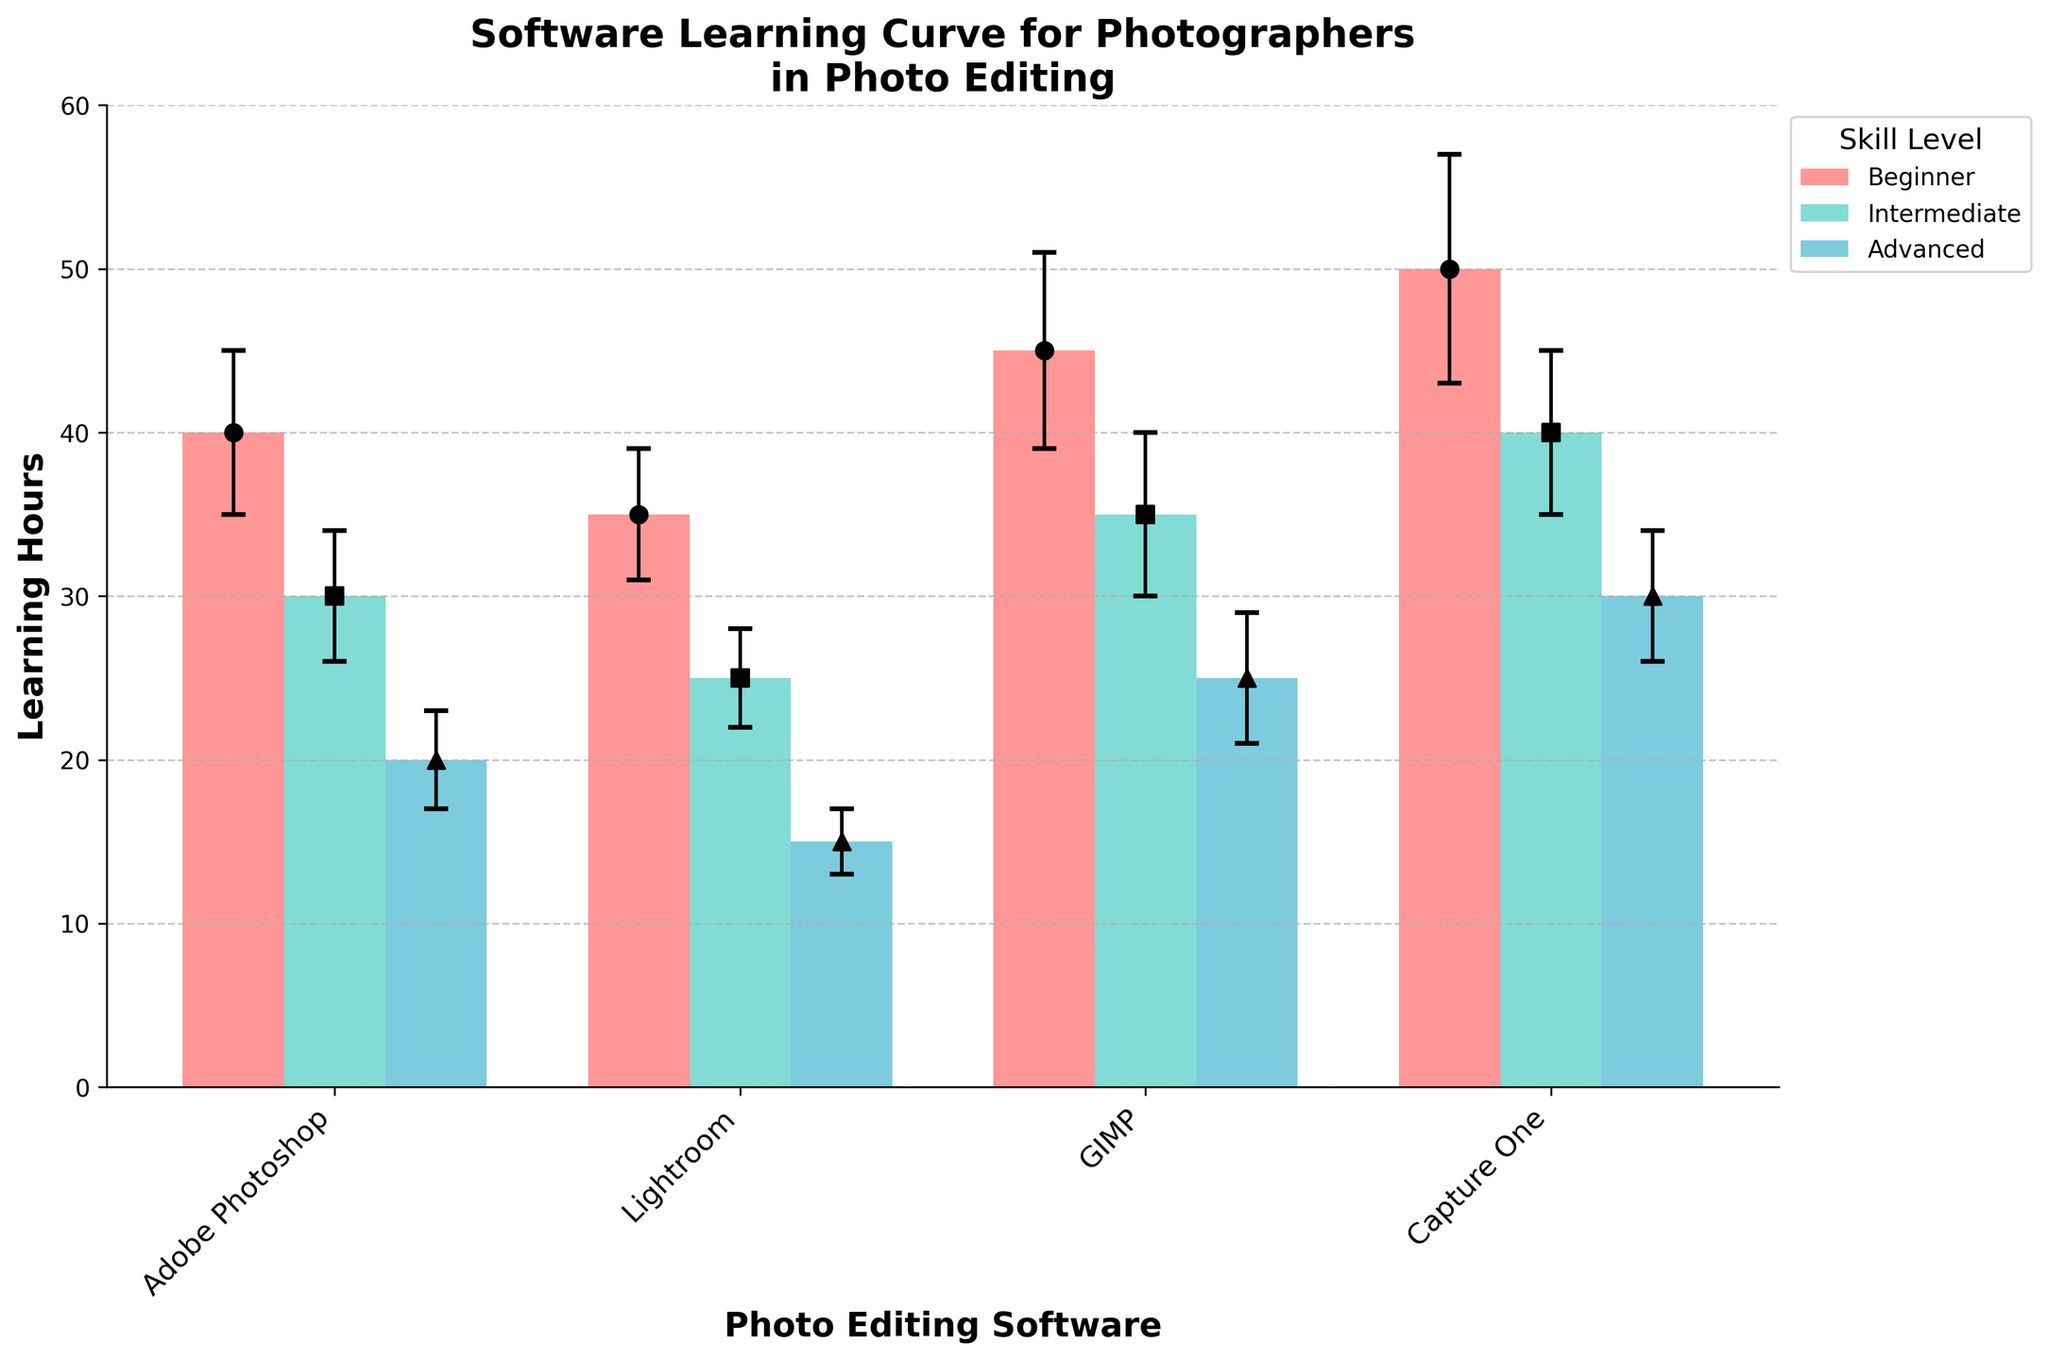What is the title of the figure? The title of the figure is located at the top and usually provides a summary of what the figure represents.
Answer: Software Learning Curve for Photographers in Photo Editing Which photo editing software requires the most learning hours for beginners? Look at the height of the bars for the Beginner skill level and compare them across different software. The tallest bar for beginners represents the software requiring the most learning hours.
Answer: Capture One What is the learning hours range for Adobe Photoshop across all skill levels? Identify the learning hours for each skill level (Beginner, Intermediate, Advanced) for Adobe Photoshop and subtract the minimum from the maximum to find the range.
Answer: 20 learning hours Which software has the least variation in learning hours from beginner to advanced? Compare the differences in learning hours between beginner and advanced skill levels for each software. The software with the smallest difference has the least variation.
Answer: Lightroom How do the error bars for Capture One compare to the others? Examine the length of the error bars for Capture One and compare them to the error bars of other software to see if they are larger, smaller, or about the same.
Answer: Larger Which skill level consistently requires fewer learning hours across all software tools? Look at the bar heights for all software categories and determine which skill level generally has the lowest bars across the board.
Answer: Advanced What is the difference in learning hours between Intermediate and Beginner skill levels for GIMP? Subtract the learning hours for the Intermediate skill level from those of the Beginner skill level for GIMP to find the difference.
Answer: 10 learning hours Which software shows the greatest decrease in learning hours from Beginner to Advanced? For each software, calculate the decrease in learning hours from Beginner to Advanced by subtracting the Advanced learning hours from the Beginner learning hours, and identify the largest decrease.
Answer: Capture One What do the colors and markers signify in the plot? The legend indicates that different colors and markers are used to represent different skill levels. Identify these from the legend.
Answer: Skill levels (Beginner, Intermediate, Advanced) In which software does the Intermediate skill level have the most learning hours? Compare the bars representing the Intermediate skill level for each software and find the one with the greatest height.
Answer: Capture One 